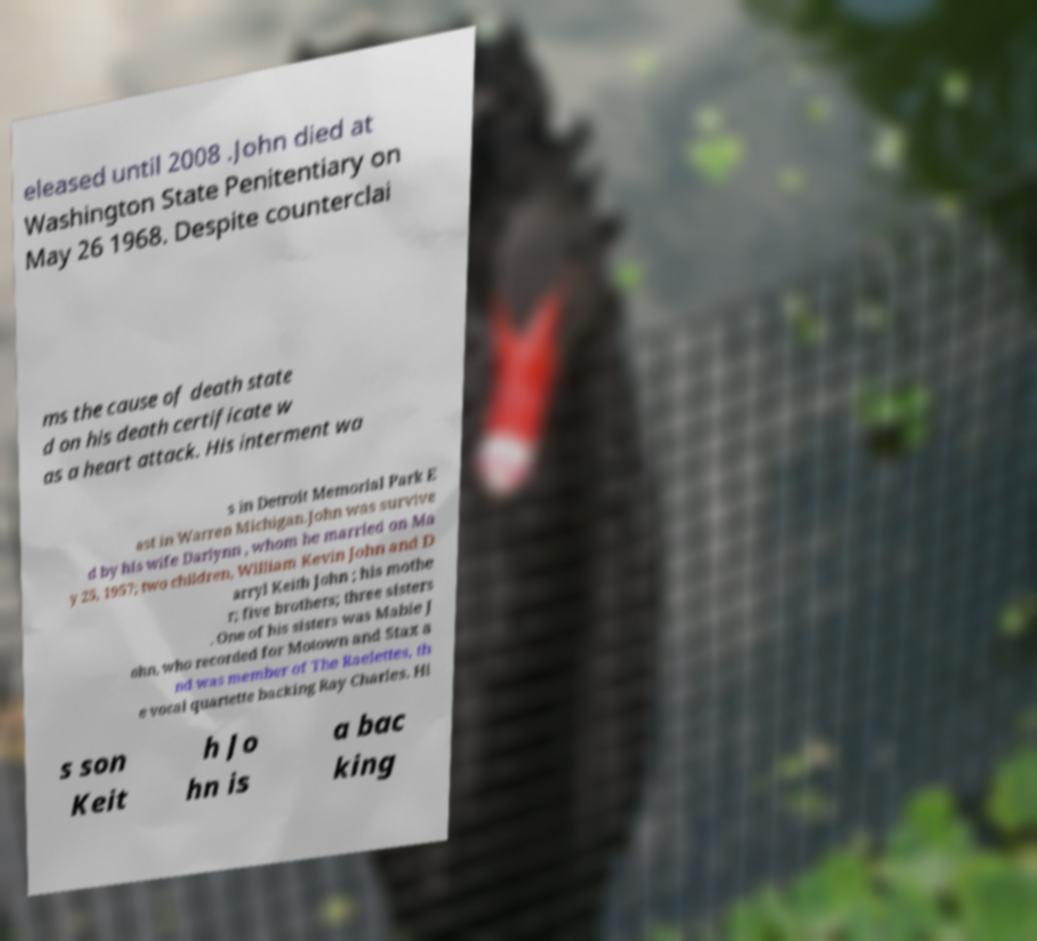Can you read and provide the text displayed in the image?This photo seems to have some interesting text. Can you extract and type it out for me? eleased until 2008 .John died at Washington State Penitentiary on May 26 1968. Despite counterclai ms the cause of death state d on his death certificate w as a heart attack. His interment wa s in Detroit Memorial Park E ast in Warren Michigan.John was survive d by his wife Darlynn , whom he married on Ma y 25, 1957; two children, William Kevin John and D arryl Keith John ; his mothe r; five brothers; three sisters . One of his sisters was Mable J ohn, who recorded for Motown and Stax a nd was member of The Raelettes, th e vocal quartette backing Ray Charles. Hi s son Keit h Jo hn is a bac king 